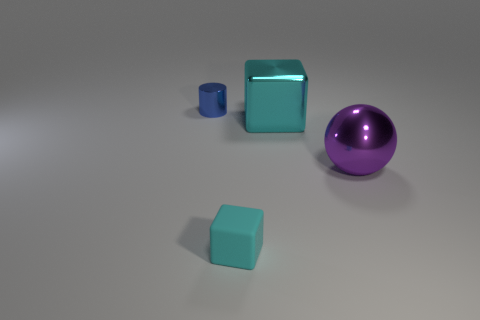Add 1 small red metallic things. How many objects exist? 5 Subtract all spheres. How many objects are left? 3 Subtract all large purple metallic things. Subtract all large cyan things. How many objects are left? 2 Add 2 cubes. How many cubes are left? 4 Add 1 green cylinders. How many green cylinders exist? 1 Subtract 1 cyan blocks. How many objects are left? 3 